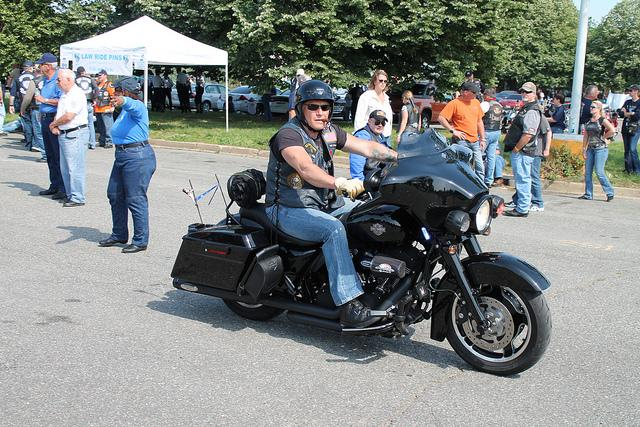What is the man with the helmet on wearing? Please explain your reasoning. sunglasses. He is in the sun and it can be bright on the eyes. 